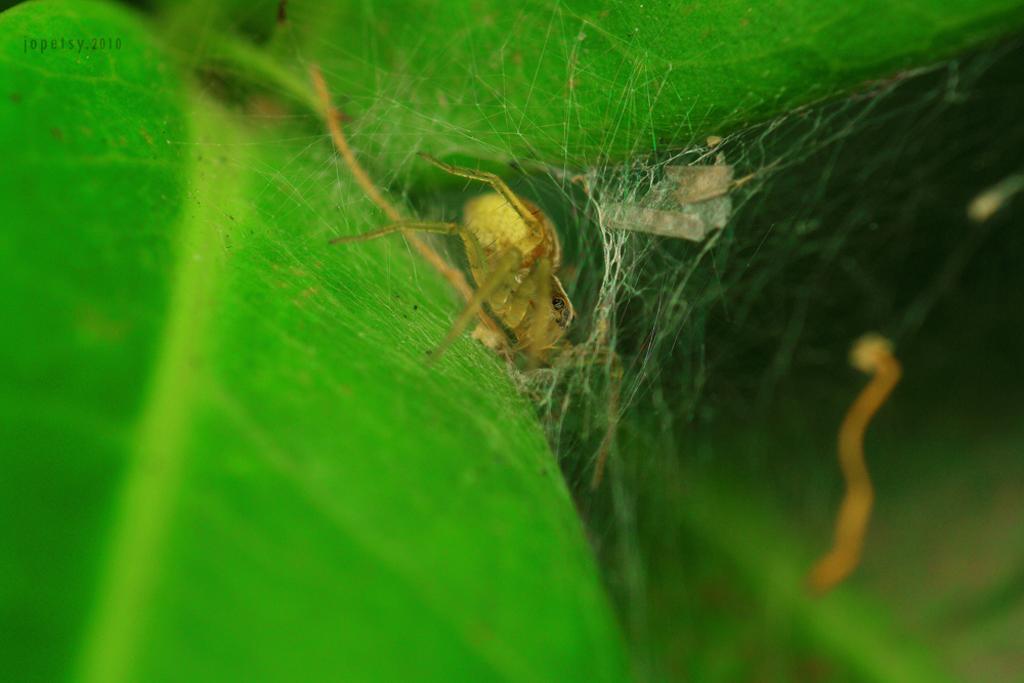In one or two sentences, can you explain what this image depicts? In this image in the center there is one spider and web, in the background there is a plant. 